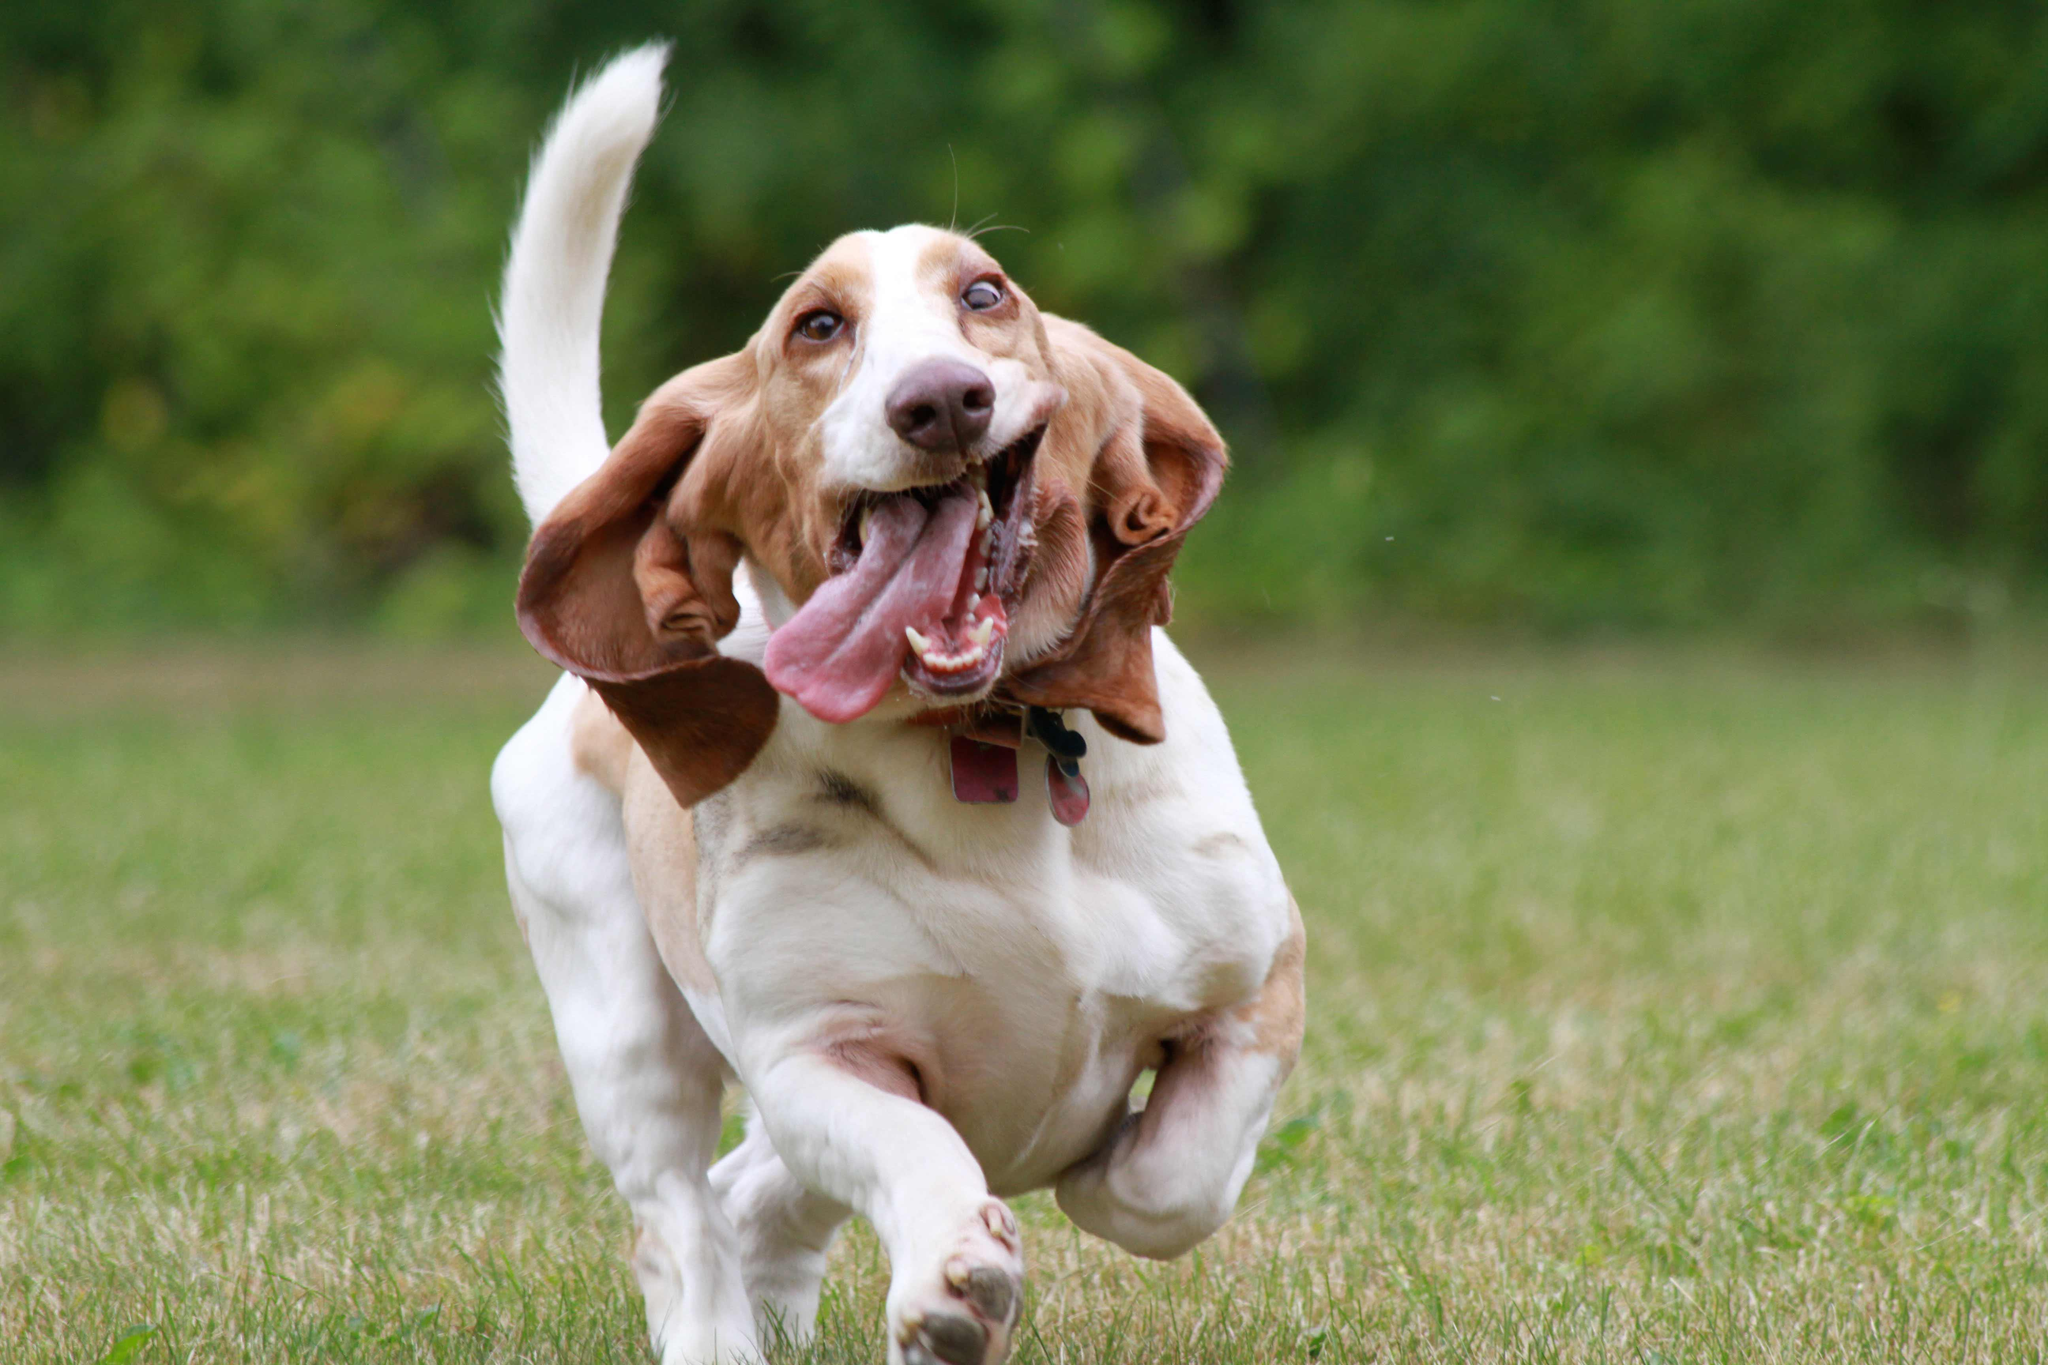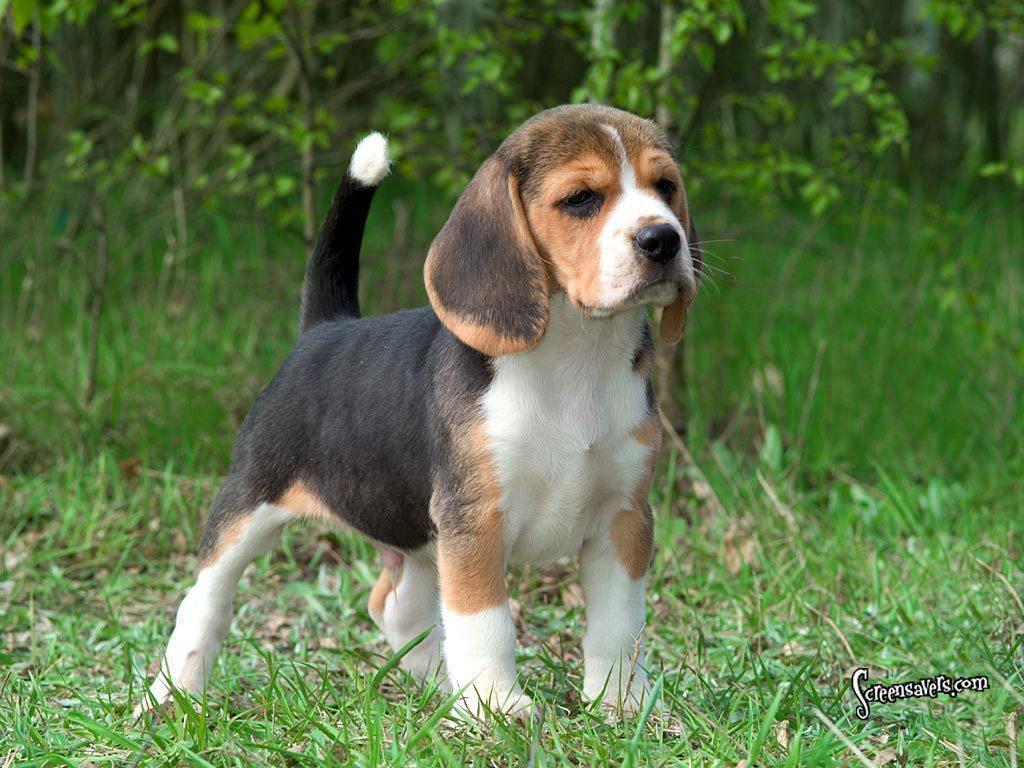The first image is the image on the left, the second image is the image on the right. Analyze the images presented: Is the assertion "Right and left images contain the same number of dogs." valid? Answer yes or no. Yes. 